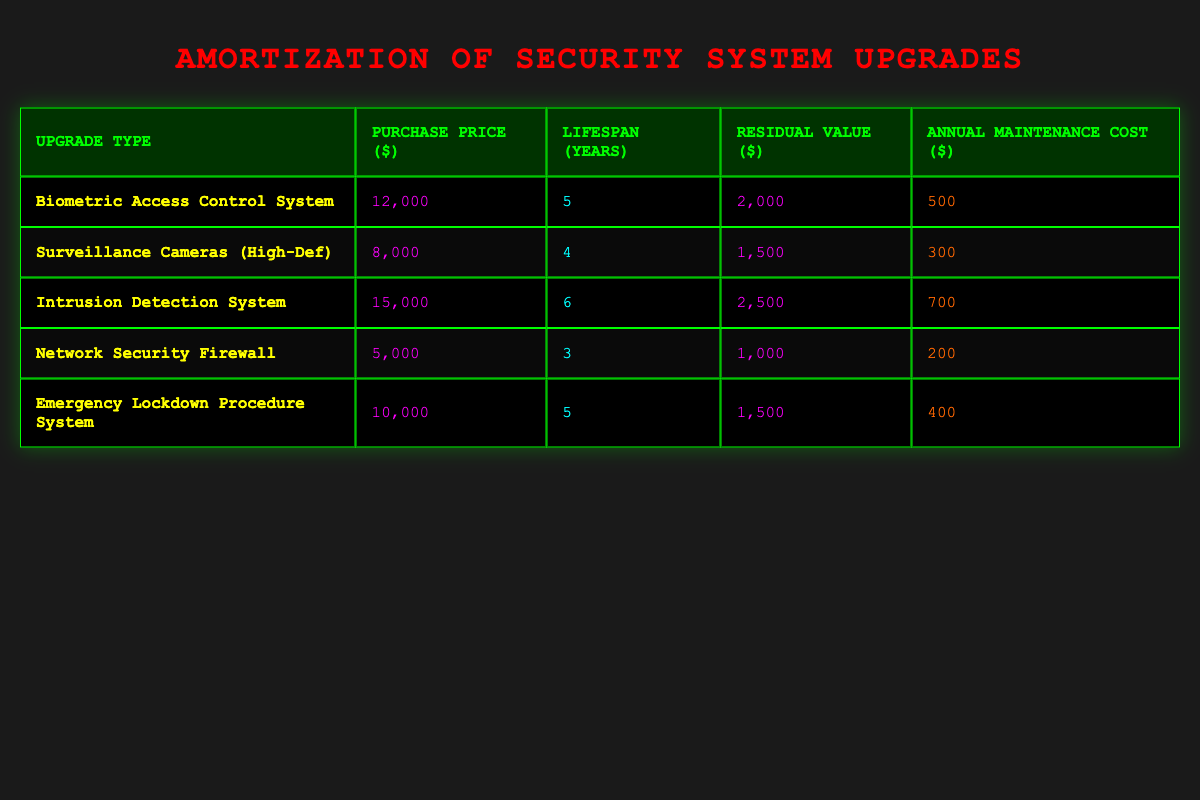What is the purchase price of the Network Security Firewall? The table lists the purchase price for each upgrade type. Looking at the row for the Network Security Firewall, the purchase price is explicitly stated as 5000.
Answer: 5000 What is the lifespan of the Surveillance Cameras? The lifespan for each security upgrade is provided in the respective rows. For the Surveillance Cameras (High-Def), the lifespan is specified as 4 years.
Answer: 4 years Which upgrade has the highest annual maintenance cost? By comparing the annual maintenance costs in the table, the Intrusion Detection System has the highest cost at 700. Other costs are lower (500, 300, 200, 400) for the other upgrades.
Answer: Intrusion Detection System What is the total purchase price of all security system upgrades combined? To find the total purchase price, sum all the purchase prices listed: 12000 + 8000 + 15000 + 5000 + 10000 = 58000.
Answer: 58000 Is the residual value of the Emergency Lockdown Procedure System greater than 1000? The residual value for this system is listed as 1500, which is greater than 1000. This is a straightforward comparison of the values provided.
Answer: Yes What is the average lifespan of the security system upgrades? The lifespans of the upgrades are 5, 4, 6, 3, and 5 years. To find the average, sum these values: 5 + 4 + 6 + 3 + 5 = 23. There are 5 upgrades, so the average lifespan is 23 / 5 = 4.6.
Answer: 4.6 years How much more is the purchase price of the Intrusion Detection System compared to the Network Security Firewall? The purchase price of the Intrusion Detection System is 15000, while that of the Network Security Firewall is 5000. The difference is 15000 - 5000 = 10000.
Answer: 10000 Are the annual maintenance costs for Surveillance Cameras and Network Security Firewall equal? The annual maintenance cost for Surveillance Cameras is 300 and for Network Security Firewall is 200. Since these values are different, the answer is no.
Answer: No Which upgrades have a lifespan of 5 years? Looking at the table, the upgrades with a lifespan of 5 years are the Biometric Access Control System and the Emergency Lockdown Procedure System. This involves checking the lifespan column for each upgrade.
Answer: Biometric Access Control System, Emergency Lockdown Procedure System 